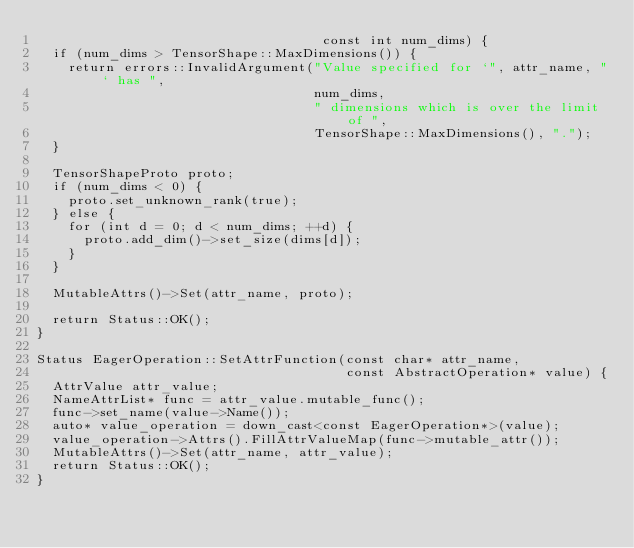<code> <loc_0><loc_0><loc_500><loc_500><_C++_>                                    const int num_dims) {
  if (num_dims > TensorShape::MaxDimensions()) {
    return errors::InvalidArgument("Value specified for `", attr_name, "` has ",
                                   num_dims,
                                   " dimensions which is over the limit of ",
                                   TensorShape::MaxDimensions(), ".");
  }

  TensorShapeProto proto;
  if (num_dims < 0) {
    proto.set_unknown_rank(true);
  } else {
    for (int d = 0; d < num_dims; ++d) {
      proto.add_dim()->set_size(dims[d]);
    }
  }

  MutableAttrs()->Set(attr_name, proto);

  return Status::OK();
}

Status EagerOperation::SetAttrFunction(const char* attr_name,
                                       const AbstractOperation* value) {
  AttrValue attr_value;
  NameAttrList* func = attr_value.mutable_func();
  func->set_name(value->Name());
  auto* value_operation = down_cast<const EagerOperation*>(value);
  value_operation->Attrs().FillAttrValueMap(func->mutable_attr());
  MutableAttrs()->Set(attr_name, attr_value);
  return Status::OK();
}
</code> 